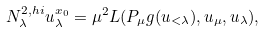Convert formula to latex. <formula><loc_0><loc_0><loc_500><loc_500>N _ { \lambda } ^ { 2 , h i } u _ { \lambda } ^ { x _ { 0 } } = \mu ^ { 2 } L ( P _ { \mu } g ( u _ { < \lambda } ) , u _ { \mu } , u _ { \lambda } ) ,</formula> 